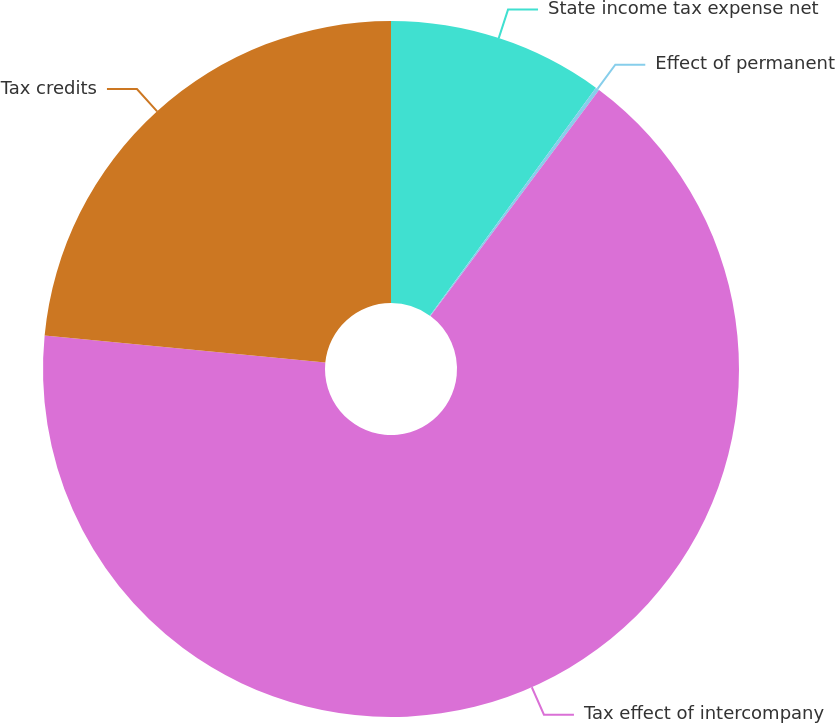<chart> <loc_0><loc_0><loc_500><loc_500><pie_chart><fcel>State income tax expense net<fcel>Effect of permanent<fcel>Tax effect of intercompany<fcel>Tax credits<nl><fcel>10.02%<fcel>0.18%<fcel>66.34%<fcel>23.46%<nl></chart> 